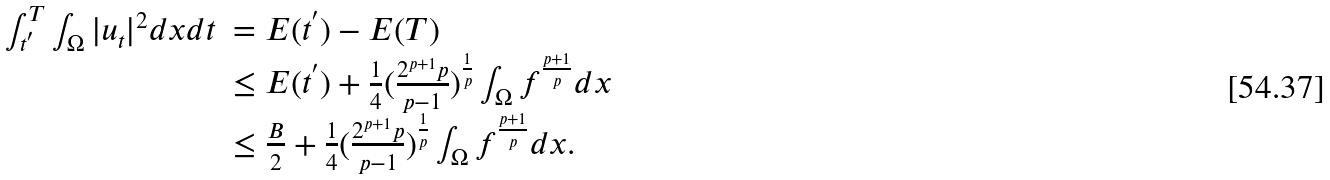Convert formula to latex. <formula><loc_0><loc_0><loc_500><loc_500>\begin{array} { l l } \int ^ { T } _ { t ^ { ^ { \prime } } } \int _ { \Omega } | u _ { t } | ^ { 2 } d x d t & = E ( t ^ { ^ { \prime } } ) - E ( T ) \\ & \leq E ( t ^ { ^ { \prime } } ) + \frac { 1 } { 4 } ( \frac { 2 ^ { p + 1 } p } { p - 1 } ) ^ { \frac { 1 } { p } } \int _ { \Omega } f ^ { \frac { p + 1 } { p } } d x \\ & \leq \frac { B } { 2 } + \frac { 1 } { 4 } ( \frac { 2 ^ { p + 1 } p } { p - 1 } ) ^ { \frac { 1 } { p } } \int _ { \Omega } f ^ { \frac { p + 1 } { p } } d x . \end{array}</formula> 